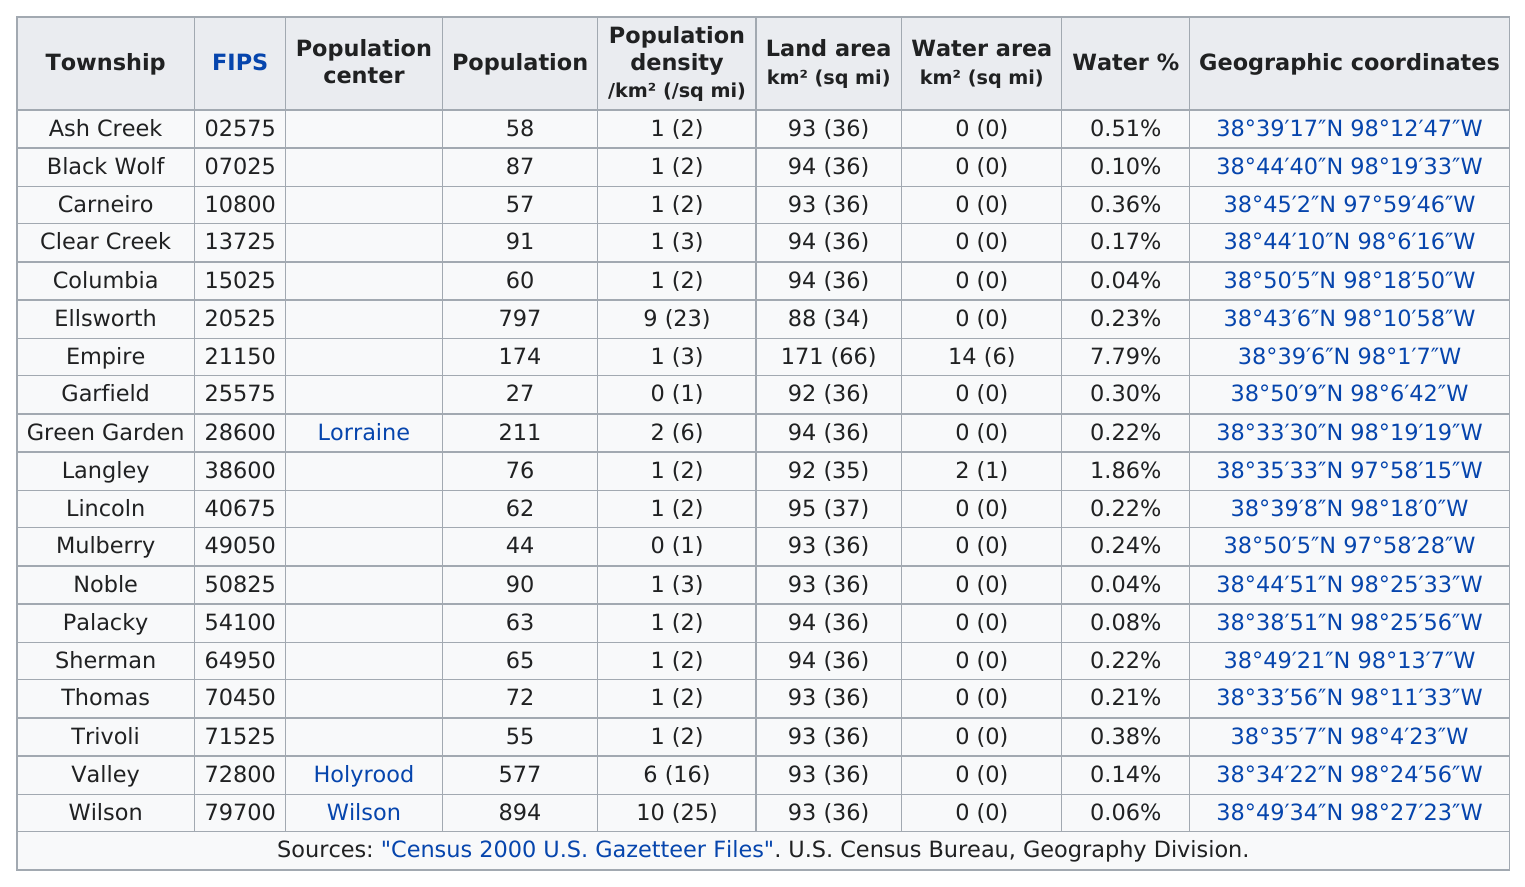Give some essential details in this illustration. Wilson is the last township in Ellsworth County, Kansas, listed alphabetically. There are 19 townships in Ellsworth County. Out of the townships surveyed, three have a minimum water percentage of 0.50 or higher. The average water content in mulberry is approximately 0.24%. The township of Thomas has a higher percentage of water compared to Columbia. 